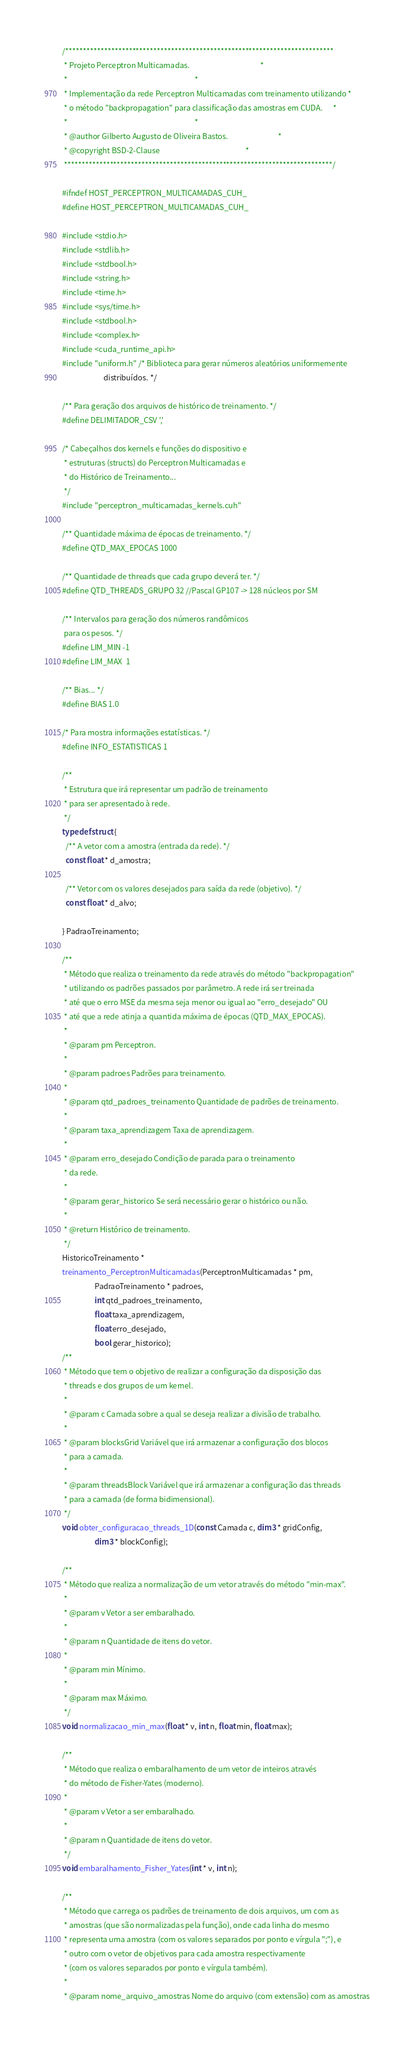<code> <loc_0><loc_0><loc_500><loc_500><_Cuda_>/****************************************************************************
 * Projeto Perceptron Multicamadas.                                         *
 *                                                                          *
 * Implementação da rede Perceptron Multicamadas com treinamento utilizando *
 * o método "backpropagation" para classificação das amostras em CUDA.      *
 *                                                                          *
 * @author Gilberto Augusto de Oliveira Bastos.                             *
 * @copyright BSD-2-Clause                                                  *
 ****************************************************************************/

#ifndef HOST_PERCEPTRON_MULTICAMADAS_CUH_
#define HOST_PERCEPTRON_MULTICAMADAS_CUH_

#include <stdio.h>
#include <stdlib.h>
#include <stdbool.h>
#include <string.h>
#include <time.h>
#include <sys/time.h>
#include <stdbool.h>
#include <complex.h>
#include <cuda_runtime_api.h>
#include "uniform.h" /* Biblioteca para gerar números aleatórios uniformemente
                        distribuídos. */

/** Para geração dos arquivos de histórico de treinamento. */
#define DELIMITADOR_CSV ','

/* Cabeçalhos dos kernels e funções do dispositivo e
 * estruturas (structs) do Perceptron Multicamadas e
 * do Histórico de Treinamento...
 */
#include "perceptron_multicamadas_kernels.cuh"

/** Quantidade máxima de épocas de treinamento. */
#define QTD_MAX_EPOCAS 1000

/** Quantidade de threads que cada grupo deverá ter. */
#define QTD_THREADS_GRUPO 32 //Pascal GP107 -> 128 núcleos por SM

/** Intervalos para geração dos números randômicos
 para os pesos. */
#define LIM_MIN -1
#define LIM_MAX  1

/** Bias... */
#define BIAS 1.0

/* Para mostra informações estatísticas. */
#define INFO_ESTATISTICAS 1

/**
 * Estrutura que irá representar um padrão de treinamento
 * para ser apresentado à rede.
 */
typedef struct {
  /** A vetor com a amostra (entrada da rede). */
  const float * d_amostra;
  
  /** Vetor com os valores desejados para saída da rede (objetivo). */
  const float * d_alvo;

} PadraoTreinamento;

/**
 * Método que realiza o treinamento da rede através do método "backpropagation"
 * utilizando os padrões passados por parâmetro. A rede irá ser treinada
 * até que o erro MSE da mesma seja menor ou igual ao "erro_desejado" OU
 * até que a rede atinja a quantida máxima de épocas (QTD_MAX_EPOCAS).
 *
 * @param pm Perceptron.
 *
 * @param padroes Padrões para treinamento.
 *
 * @param qtd_padroes_treinamento Quantidade de padrões de treinamento.
 *
 * @param taxa_aprendizagem Taxa de aprendizagem.
 *
 * @param erro_desejado Condição de parada para o treinamento
 * da rede.
 *
 * @param gerar_historico Se será necessário gerar o histórico ou não.
 *
 * @return Histórico de treinamento.
 */
HistoricoTreinamento *
treinamento_PerceptronMulticamadas(PerceptronMulticamadas * pm,
				   PadraoTreinamento * padroes,
				   int qtd_padroes_treinamento,
				   float taxa_aprendizagem,
				   float erro_desejado,
				   bool gerar_historico);
/**
 * Método que tem o objetivo de realizar a configuração da disposição das
 * threads e dos grupos de um kernel.
 *
 * @param c Camada sobre a qual se deseja realizar a divisão de trabalho.
 *
 * @param blocksGrid Variável que irá armazenar a configuração dos blocos
 * para a camada.
 *
 * @param threadsBlock Variável que irá armazenar a configuração das threads
 * para a camada (de forma bidimensional).
 */
void obter_configuracao_threads_1D(const Camada c, dim3 * gridConfig,
				   dim3 * blockConfig);

/**
 * Método que realiza a normalização de um vetor através do método "min-max".
 *
 * @param v Vetor a ser embaralhado.
 *
 * @param n Quantidade de itens do vetor.
 *
 * @param min Mínimo.
 *
 * @param max Máximo.
 */
void normalizacao_min_max(float * v, int n, float min, float max);

/**
 * Método que realiza o embaralhamento de um vetor de inteiros através
 * do método de Fisher-Yates (moderno).
 *
 * @param v Vetor a ser embaralhado.
 *
 * @param n Quantidade de itens do vetor.
 */
void embaralhamento_Fisher_Yates(int * v, int n);

/**
 * Método que carrega os padrões de treinamento de dois arquivos, um com as
 * amostras (que são normalizadas pela função), onde cada linha do mesmo
 * representa uma amostra (com os valores separados por ponto e vírgula ";"), e
 * outro com o vetor de objetivos para cada amostra respectivamente
 * (com os valores separados por ponto e vírgula também).
 *
 * @param nome_arquivo_amostras Nome do arquivo (com extensão) com as amostras</code> 